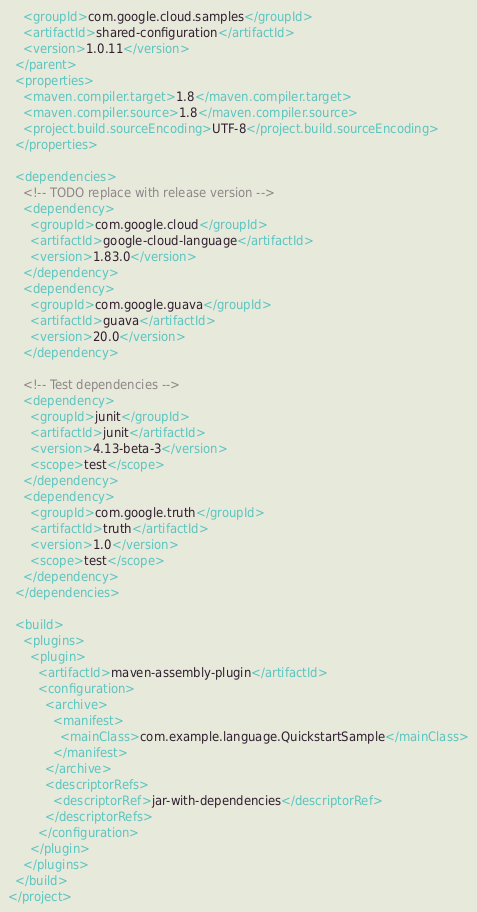<code> <loc_0><loc_0><loc_500><loc_500><_XML_>    <groupId>com.google.cloud.samples</groupId>
    <artifactId>shared-configuration</artifactId>
    <version>1.0.11</version>
  </parent>
  <properties>
    <maven.compiler.target>1.8</maven.compiler.target>
    <maven.compiler.source>1.8</maven.compiler.source>
    <project.build.sourceEncoding>UTF-8</project.build.sourceEncoding>
  </properties>

  <dependencies>
    <!-- TODO replace with release version -->
    <dependency>
      <groupId>com.google.cloud</groupId>
      <artifactId>google-cloud-language</artifactId>
      <version>1.83.0</version>
    </dependency>
    <dependency>
      <groupId>com.google.guava</groupId>
      <artifactId>guava</artifactId>
      <version>20.0</version>
    </dependency>

    <!-- Test dependencies -->
    <dependency>
      <groupId>junit</groupId>
      <artifactId>junit</artifactId>
      <version>4.13-beta-3</version>
      <scope>test</scope>
    </dependency>
    <dependency>
      <groupId>com.google.truth</groupId>
      <artifactId>truth</artifactId>
      <version>1.0</version>
      <scope>test</scope>
    </dependency>
  </dependencies>

  <build>
    <plugins>
      <plugin>
        <artifactId>maven-assembly-plugin</artifactId>
        <configuration>
          <archive>
            <manifest>
              <mainClass>com.example.language.QuickstartSample</mainClass>
            </manifest>
          </archive>
          <descriptorRefs>
            <descriptorRef>jar-with-dependencies</descriptorRef>
          </descriptorRefs>
        </configuration>
      </plugin>
    </plugins>
  </build>
</project>
</code> 